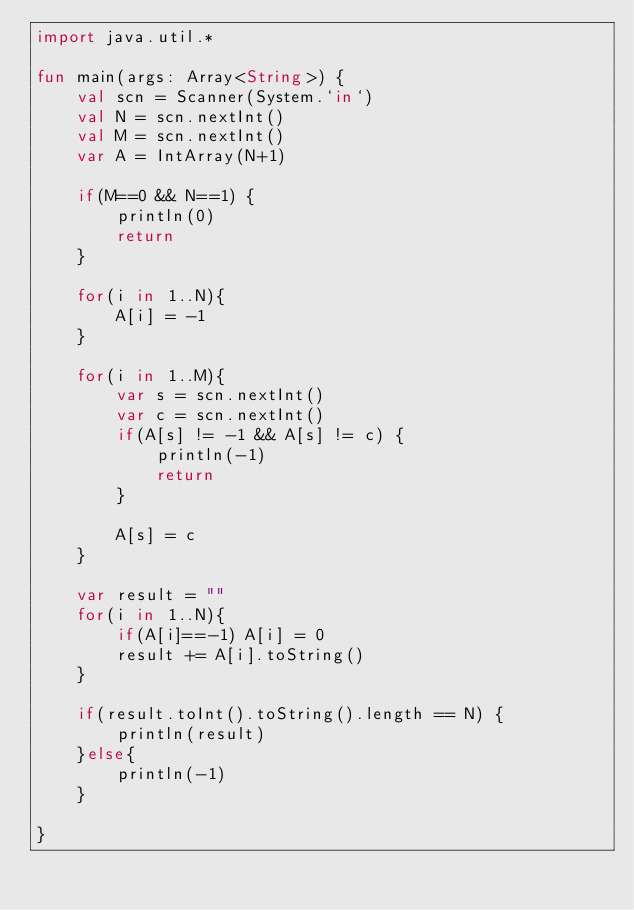Convert code to text. <code><loc_0><loc_0><loc_500><loc_500><_Kotlin_>import java.util.*

fun main(args: Array<String>) {
    val scn = Scanner(System.`in`)
    val N = scn.nextInt()
    val M = scn.nextInt()
    var A = IntArray(N+1)

    if(M==0 && N==1) {
        println(0)
        return
    }

    for(i in 1..N){
        A[i] = -1
    }

    for(i in 1..M){
        var s = scn.nextInt()
        var c = scn.nextInt()
        if(A[s] != -1 && A[s] != c) {
            println(-1)
            return
        }

        A[s] = c
    }

    var result = ""
    for(i in 1..N){
        if(A[i]==-1) A[i] = 0
        result += A[i].toString()
    }

    if(result.toInt().toString().length == N) {
        println(result)
    }else{
        println(-1)
    }

}</code> 